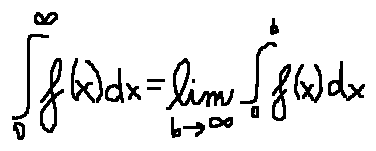<formula> <loc_0><loc_0><loc_500><loc_500>\int \lim i t s _ { 0 } ^ { \infty } f ( x ) d x = \lim \lim i t s _ { b \rightarrow \infty } \int \lim i t s _ { 0 } ^ { b } f ( x ) d x</formula> 